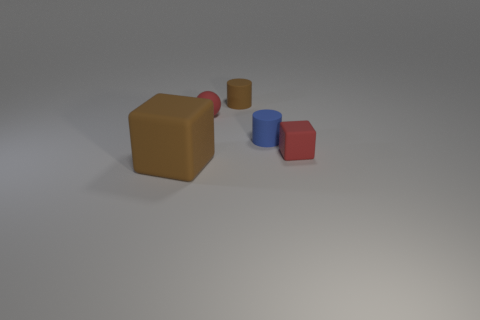Are there any cyan spheres that have the same material as the blue cylinder?
Provide a short and direct response. No. There is a blue thing; does it have the same size as the red thing that is to the left of the tiny brown matte object?
Make the answer very short. Yes. Are there any large things of the same color as the tiny rubber block?
Give a very brief answer. No. Does the big brown object have the same material as the blue thing?
Give a very brief answer. Yes. How many rubber blocks are on the left side of the sphere?
Offer a terse response. 1. The tiny thing that is behind the small red rubber cube and in front of the matte ball is made of what material?
Provide a succinct answer. Rubber. How many brown rubber objects are the same size as the red matte sphere?
Your answer should be very brief. 1. The cube on the left side of the cube that is behind the brown cube is what color?
Give a very brief answer. Brown. Is there a brown matte block?
Your response must be concise. Yes. Is the big brown thing the same shape as the tiny blue rubber object?
Give a very brief answer. No. 